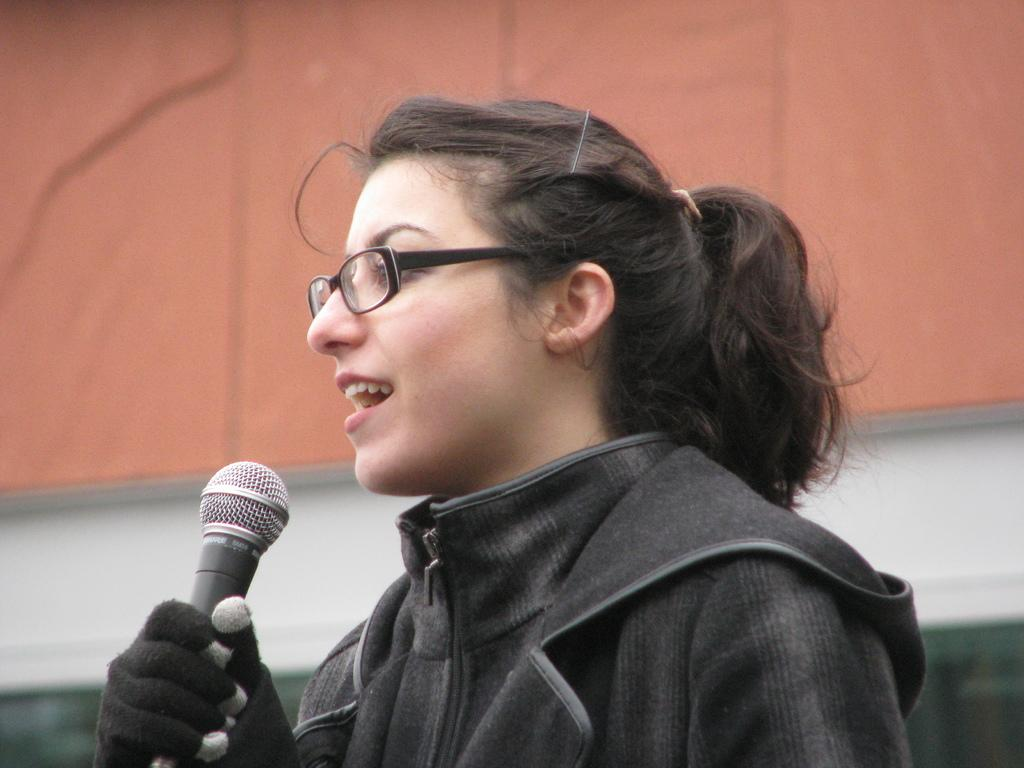What is the main subject of the image? There is a person in the image. What is the person holding in the image? The person is holding a mic. What can be seen behind the person in the image? There is a wall visible behind the person. How many apples are on the person's legs in the image? There are no apples or legs visible in the image; it only shows a person holding a mic with a wall in the background. 